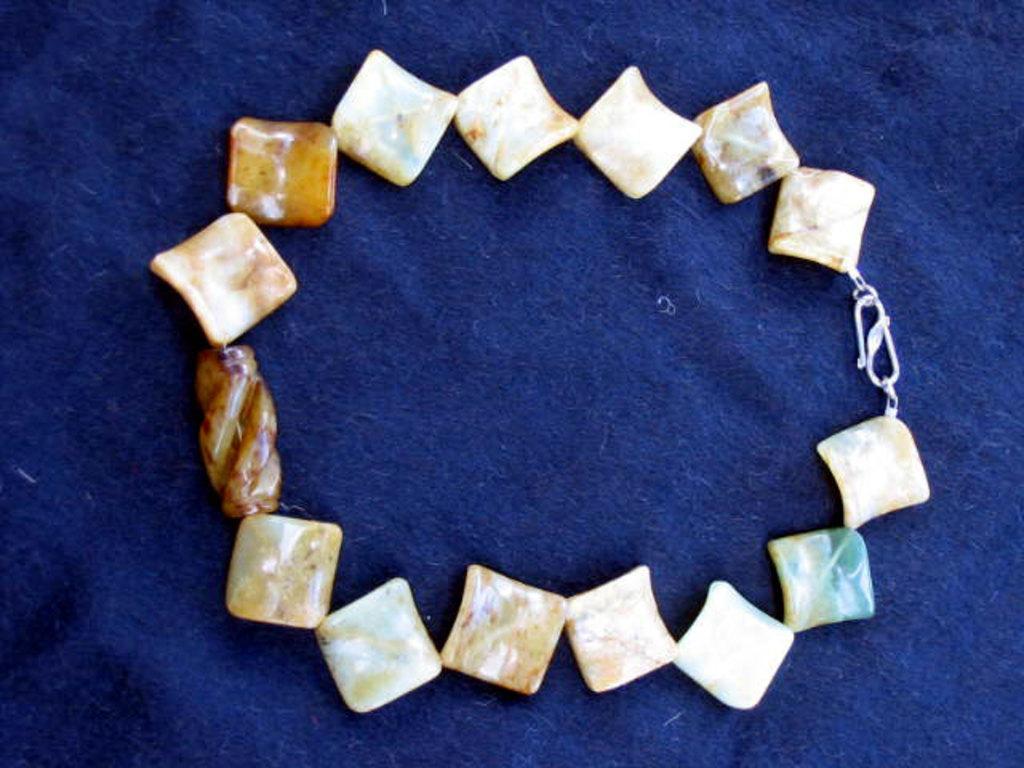In one or two sentences, can you explain what this image depicts? In this image, we can see pebbles to a chain. At the bottom, there is a blue color cloth. 